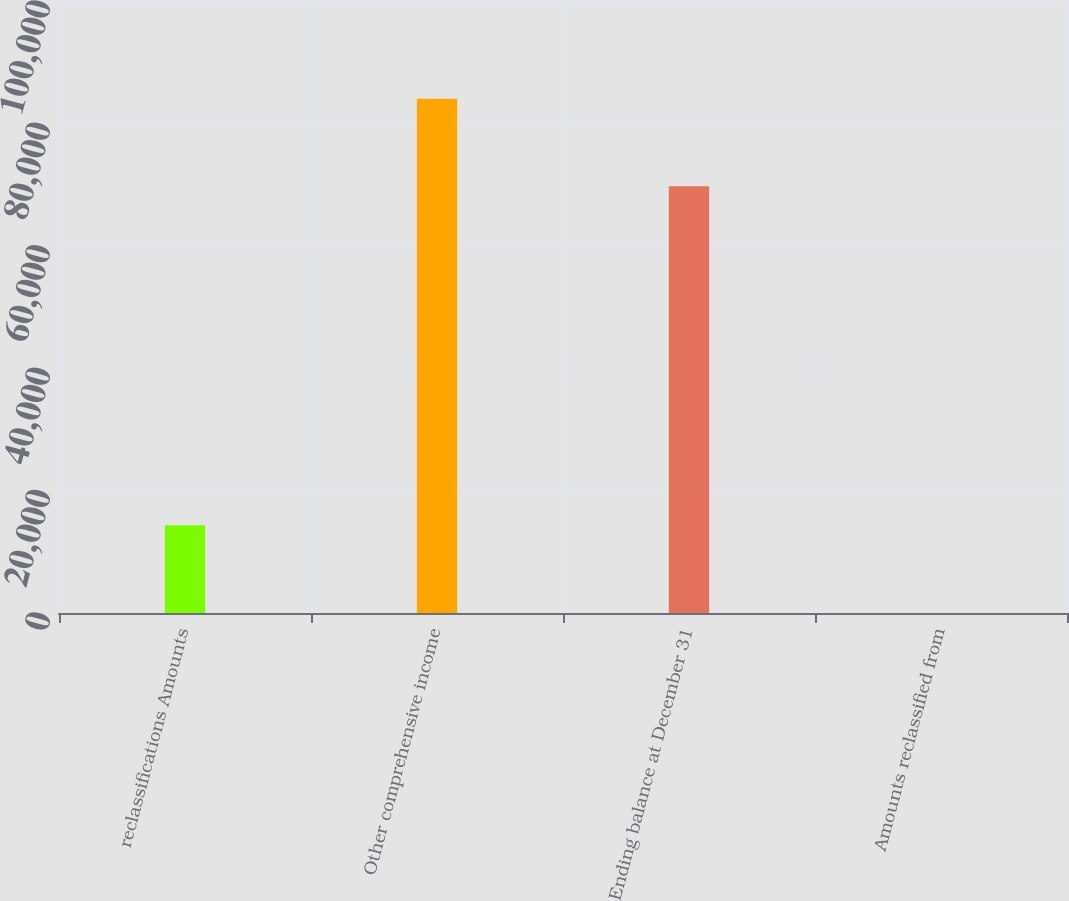<chart> <loc_0><loc_0><loc_500><loc_500><bar_chart><fcel>reclassifications Amounts<fcel>Other comprehensive income<fcel>Ending balance at December 31<fcel>Amounts reclassified from<nl><fcel>14318.5<fcel>84029.3<fcel>69711<fcel>0.2<nl></chart> 